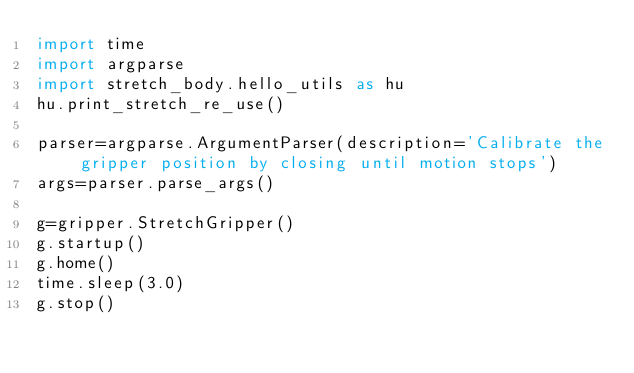<code> <loc_0><loc_0><loc_500><loc_500><_Python_>import time
import argparse
import stretch_body.hello_utils as hu
hu.print_stretch_re_use()

parser=argparse.ArgumentParser(description='Calibrate the gripper position by closing until motion stops')
args=parser.parse_args()

g=gripper.StretchGripper()
g.startup()
g.home()
time.sleep(3.0)
g.stop()</code> 